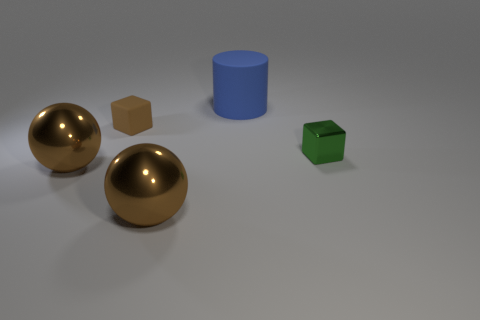Add 3 rubber cylinders. How many objects exist? 8 Subtract all green cubes. How many cubes are left? 1 Subtract 1 cylinders. How many cylinders are left? 0 Subtract all red spheres. Subtract all gray cylinders. How many spheres are left? 2 Subtract all red cylinders. How many blue cubes are left? 0 Subtract all tiny metal cubes. Subtract all big green cylinders. How many objects are left? 4 Add 5 small green shiny objects. How many small green shiny objects are left? 6 Add 4 brown matte objects. How many brown matte objects exist? 5 Subtract 0 gray spheres. How many objects are left? 5 Subtract all blocks. How many objects are left? 3 